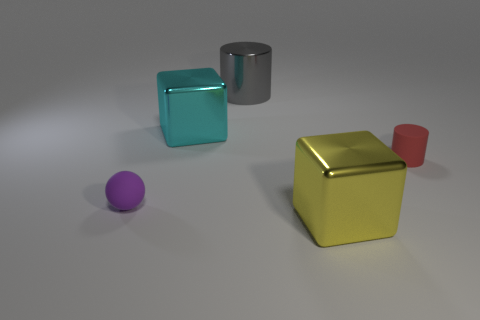Add 2 small green metallic balls. How many objects exist? 7 Subtract all balls. How many objects are left? 4 Add 1 small cyan metallic things. How many small cyan metallic things exist? 1 Subtract 0 blue balls. How many objects are left? 5 Subtract all big blue spheres. Subtract all purple rubber objects. How many objects are left? 4 Add 1 purple things. How many purple things are left? 2 